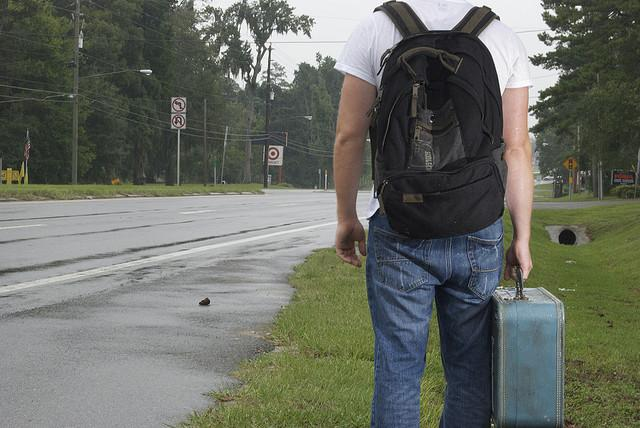What sign is on right side of the road? Please explain your reasoning. signal. The sign has the symbol that indicates that a traffic light is up ahead. 